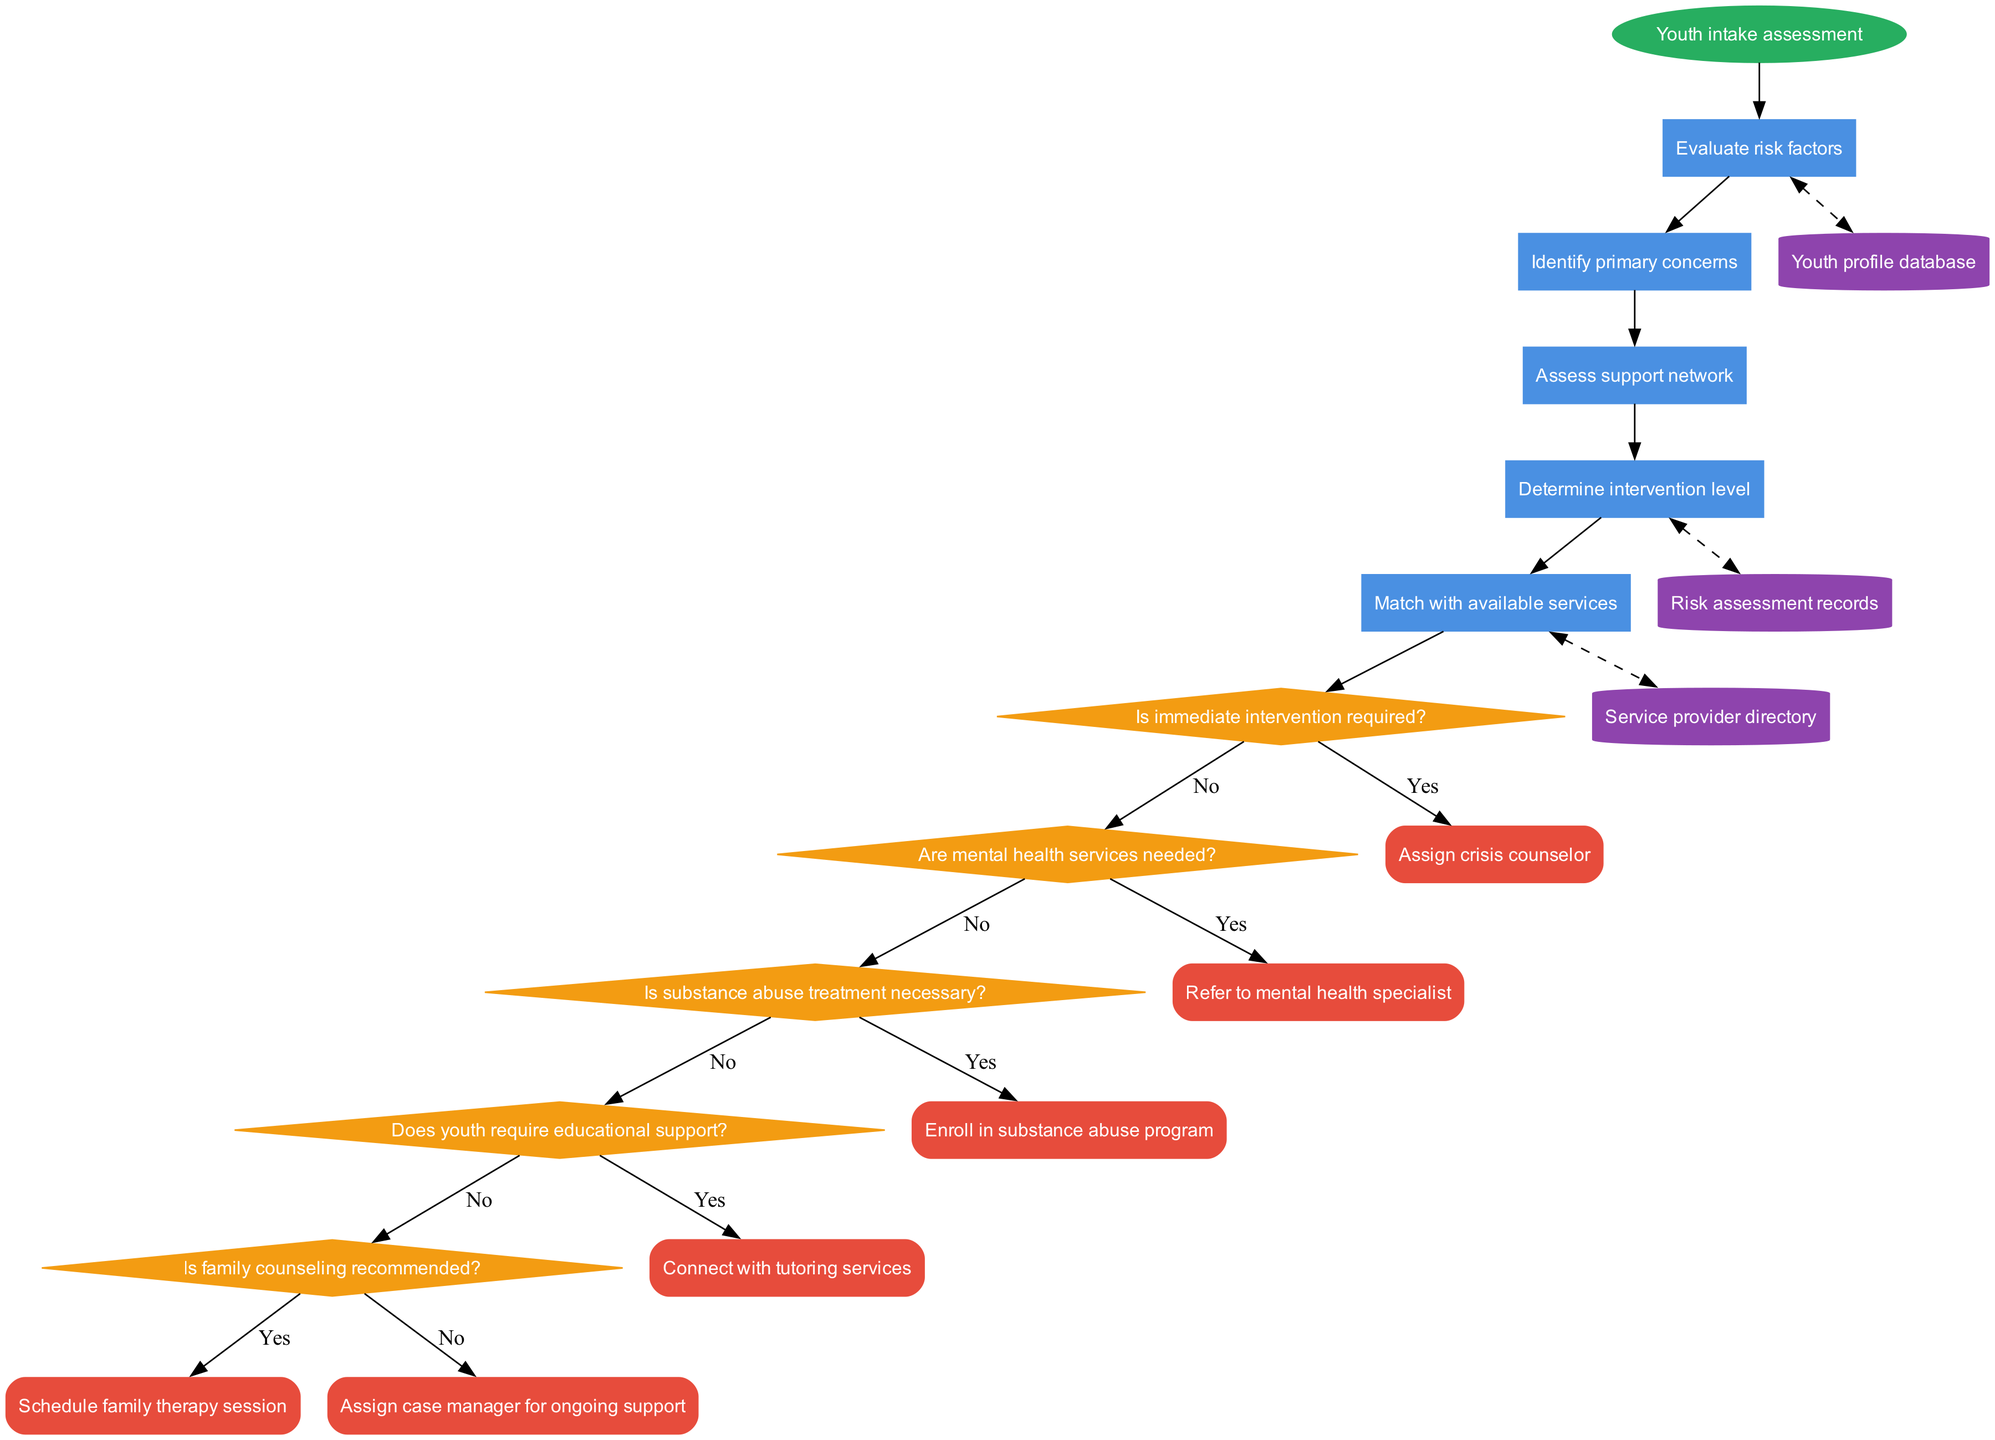What is the starting node of the flowchart? The starting node is labeled "Youth intake assessment." This can be found at the top of the diagram, indicating where the process begins.
Answer: Youth intake assessment How many processes are there in the flowchart? The flowchart contains five processes, which are listed sequentially after the starting node.
Answer: 5 Which decision follows the "Determine intervention level" process? After "Determine intervention level," the next decision is "Is immediate intervention required?" This can be traced along the edges connecting the nodes in the flowchart.
Answer: Is immediate intervention required? What is the endpoint if substance abuse treatment is necessary? If "Is substance abuse treatment necessary?" is answered with "Yes," the flowchart connects directly to "Enroll in substance abuse program," which is the corresponding endpoint for this decision.
Answer: Enroll in substance abuse program Which data store is connected to the "Evaluate risk factors" process? The "Evaluate risk factors" process has a dashed edge linking it to the "Youth profile database," indicating a bidirectional relationship where data can be shared.
Answer: Youth profile database What is the last endpoint in the flowchart? The last endpoint in the flowchart is "Schedule family therapy session," which can be identified as the final destination after processing through the earlier decisions.
Answer: Schedule family therapy session What sequence of outcomes occurs if the youth requires educational support? If "Does youth require educational support?" is answered with "Yes," it leads directly to "Connect with tutoring services," which is the next step designated for that pathway. This sequence confirms the action taken based on the earlier assessment.
Answer: Connect with tutoring services How many decisions are in the diagram? The flowchart includes five decisions, each leading to different pathways based on the youth's needs, which can be counted by reviewing all the diamond-shaped nodes.
Answer: 5 Which process connects to the "Risk assessment records" data store? The "Determine intervention level" process connects to the "Risk assessment records" data store, indicated by a dashed line showing mutual data flow between these elements.
Answer: Risk assessment records 